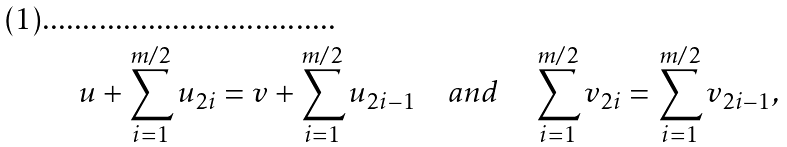Convert formula to latex. <formula><loc_0><loc_0><loc_500><loc_500>u + \sum _ { i = 1 } ^ { m / 2 } u _ { 2 i } = v + \sum _ { i = 1 } ^ { m / 2 } u _ { 2 i - 1 } \quad a n d \quad \sum _ { i = 1 } ^ { m / 2 } v _ { 2 i } = \sum _ { i = 1 } ^ { m / 2 } v _ { 2 i - 1 } ,</formula> 